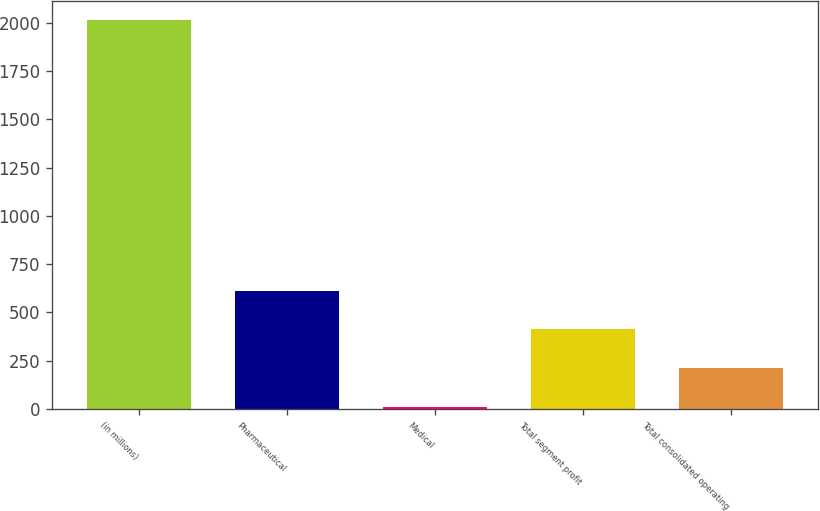Convert chart to OTSL. <chart><loc_0><loc_0><loc_500><loc_500><bar_chart><fcel>(in millions)<fcel>Pharmaceutical<fcel>Medical<fcel>Total segment profit<fcel>Total consolidated operating<nl><fcel>2011<fcel>612.4<fcel>13<fcel>412.6<fcel>212.8<nl></chart> 